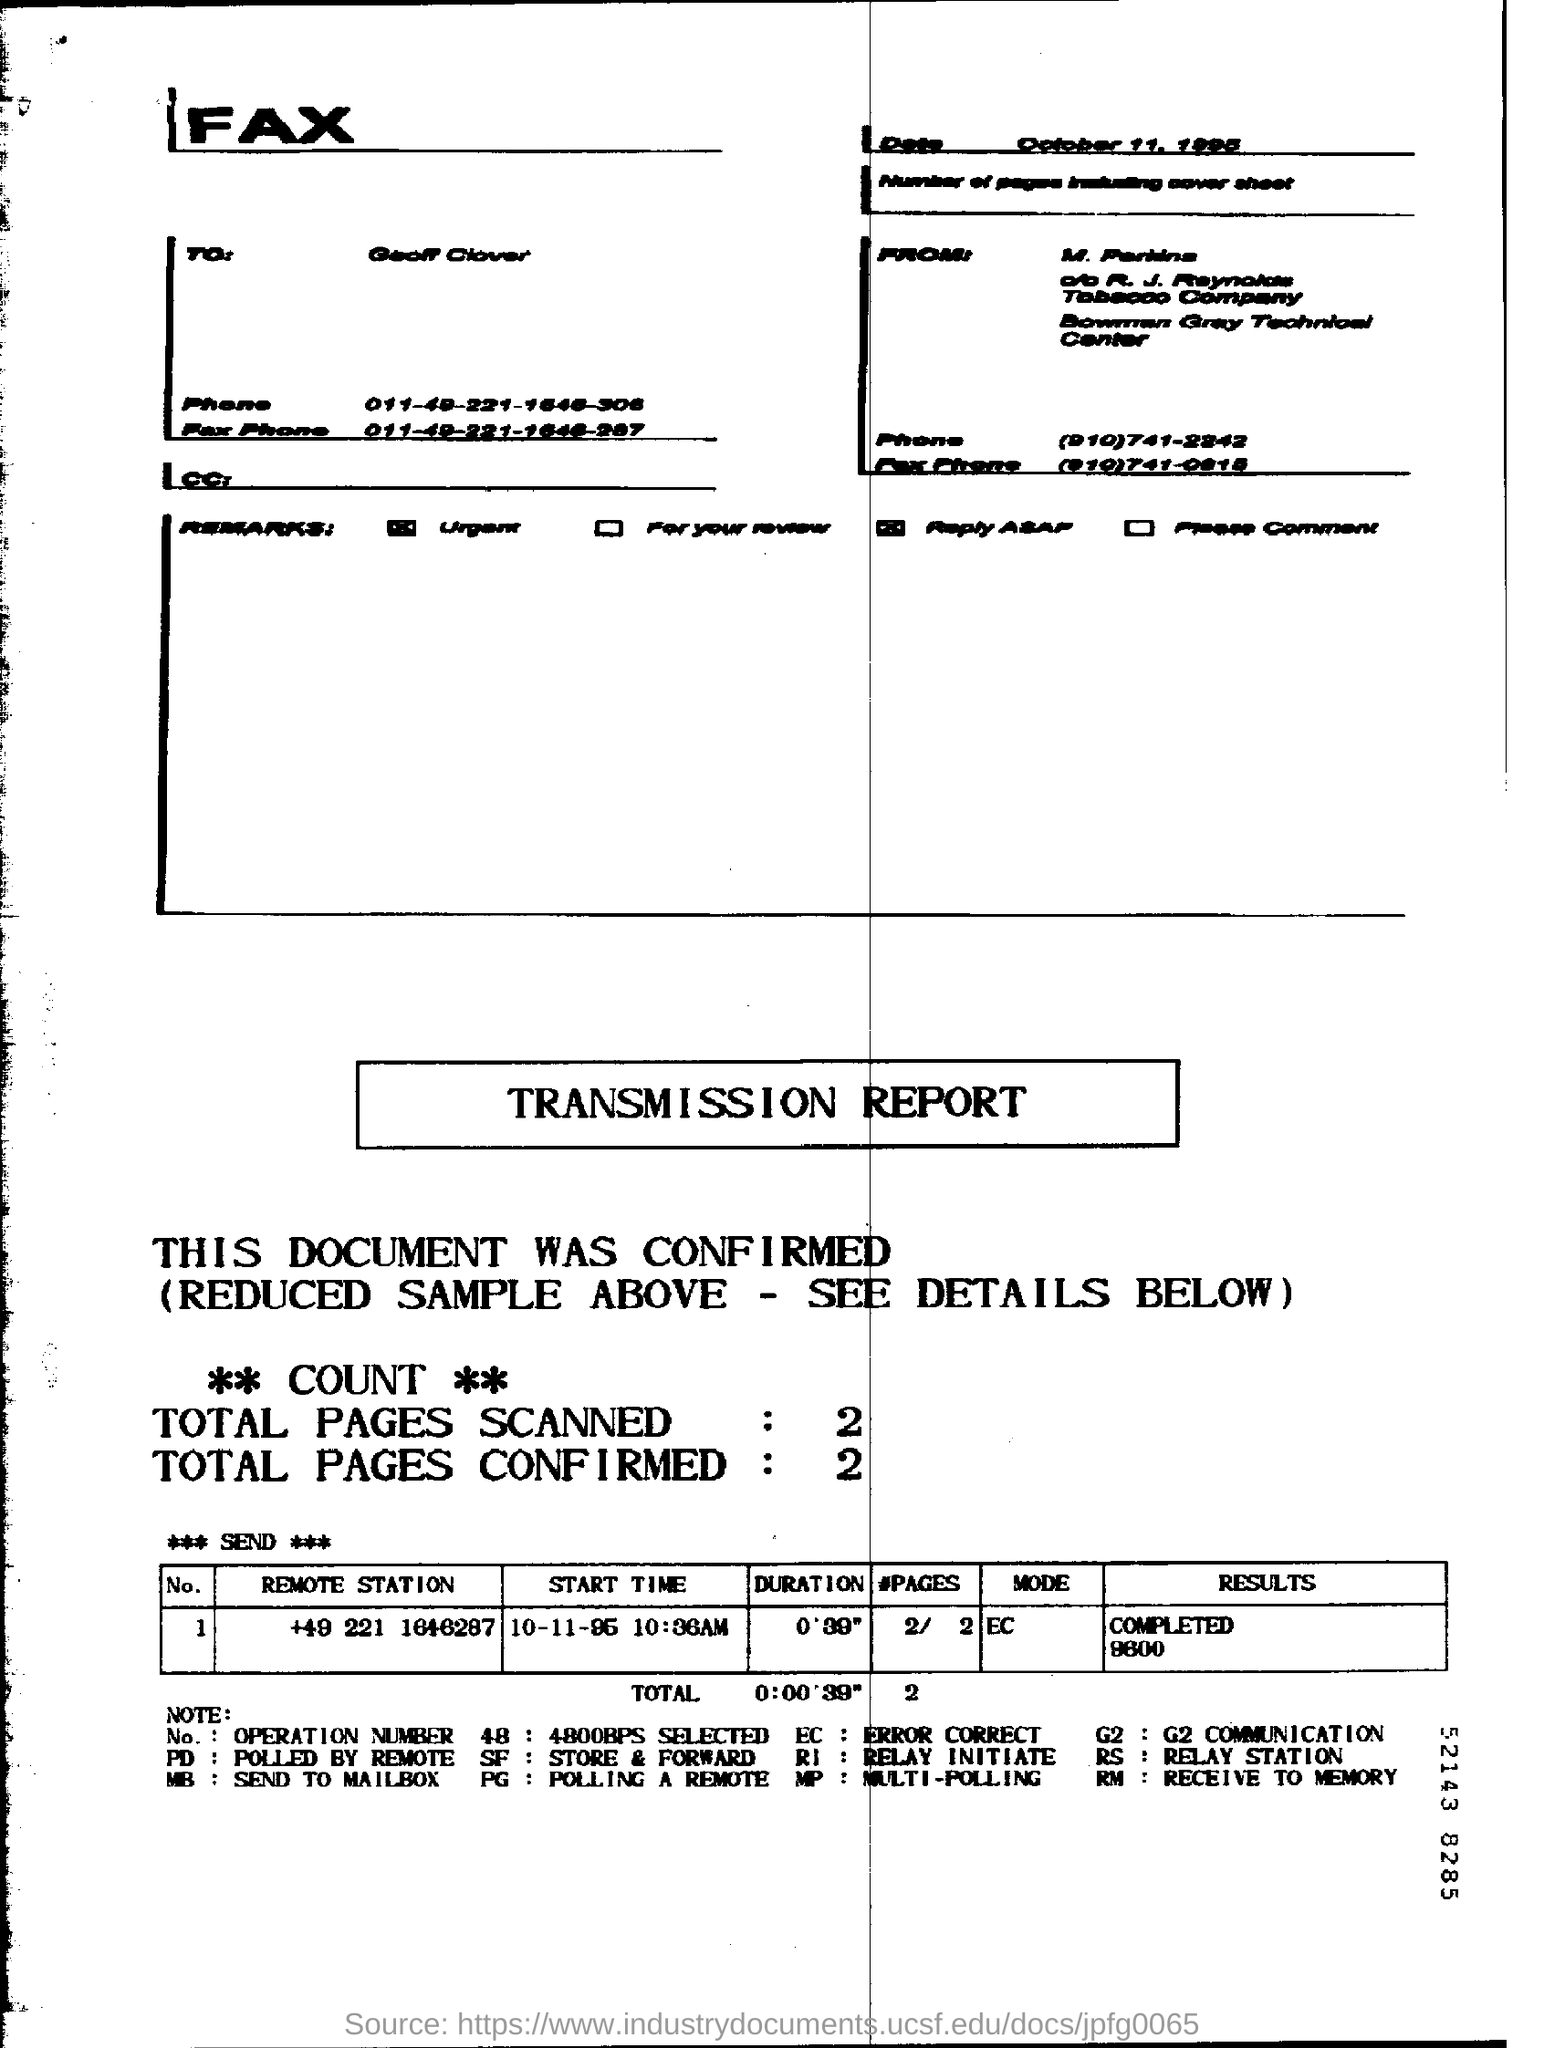What is the Date?
Offer a terse response. October 11, 1995. What is the mode for remote station +49 221 1646287?
Ensure brevity in your answer.  EC. What are the Total Pages Scanned?
Provide a short and direct response. 2. What are the Total Pages Confirmed?
Offer a very short reply. 2. 